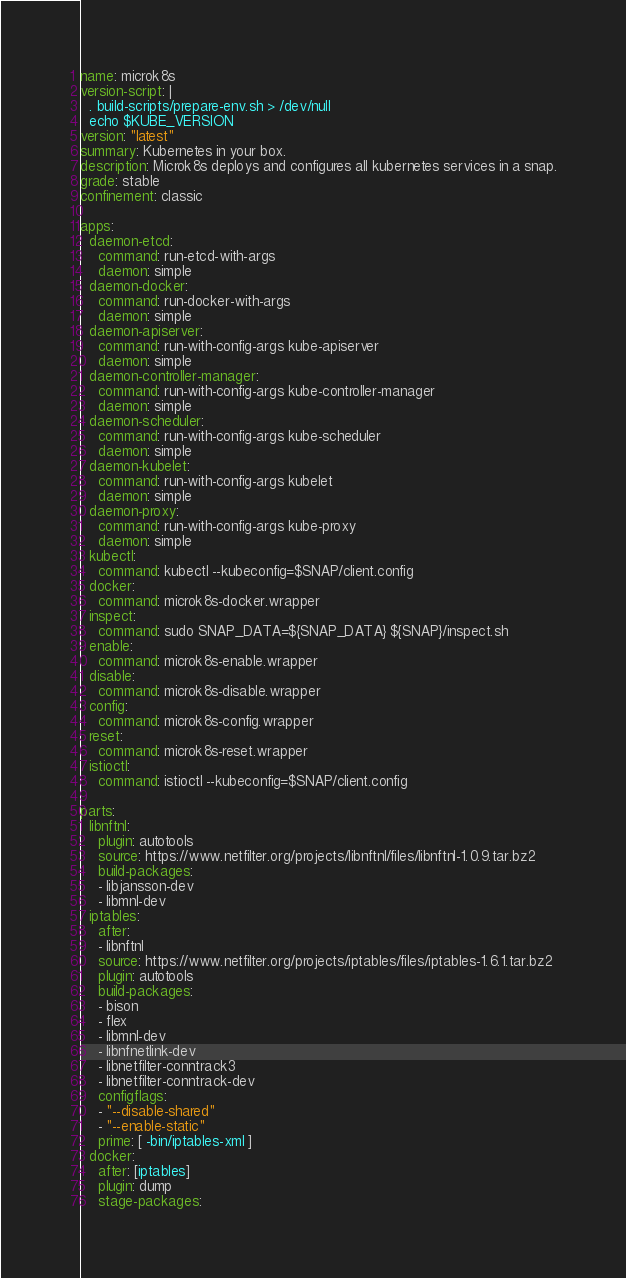<code> <loc_0><loc_0><loc_500><loc_500><_YAML_>name: microk8s
version-script: |
  . build-scripts/prepare-env.sh > /dev/null
  echo $KUBE_VERSION
version: "latest"
summary: Kubernetes in your box.
description: Microk8s deploys and configures all kubernetes services in a snap.
grade: stable
confinement: classic

apps:
  daemon-etcd:
    command: run-etcd-with-args
    daemon: simple
  daemon-docker:
    command: run-docker-with-args
    daemon: simple
  daemon-apiserver:
    command: run-with-config-args kube-apiserver
    daemon: simple
  daemon-controller-manager:
    command: run-with-config-args kube-controller-manager
    daemon: simple
  daemon-scheduler:
    command: run-with-config-args kube-scheduler
    daemon: simple
  daemon-kubelet:
    command: run-with-config-args kubelet
    daemon: simple
  daemon-proxy:
    command: run-with-config-args kube-proxy
    daemon: simple
  kubectl:
    command: kubectl --kubeconfig=$SNAP/client.config
  docker:
    command: microk8s-docker.wrapper
  inspect:
    command: sudo SNAP_DATA=${SNAP_DATA} ${SNAP}/inspect.sh
  enable:
    command: microk8s-enable.wrapper
  disable:
    command: microk8s-disable.wrapper
  config:
    command: microk8s-config.wrapper
  reset:
    command: microk8s-reset.wrapper
  istioctl:
    command: istioctl --kubeconfig=$SNAP/client.config

parts:
  libnftnl:
    plugin: autotools
    source: https://www.netfilter.org/projects/libnftnl/files/libnftnl-1.0.9.tar.bz2
    build-packages:
    - libjansson-dev
    - libmnl-dev
  iptables:
    after:
    - libnftnl
    source: https://www.netfilter.org/projects/iptables/files/iptables-1.6.1.tar.bz2
    plugin: autotools
    build-packages:
    - bison
    - flex
    - libmnl-dev
    - libnfnetlink-dev
    - libnetfilter-conntrack3
    - libnetfilter-conntrack-dev
    configflags:
    - "--disable-shared"
    - "--enable-static"
    prime: [ -bin/iptables-xml ]
  docker:
    after: [iptables]
    plugin: dump
    stage-packages:</code> 